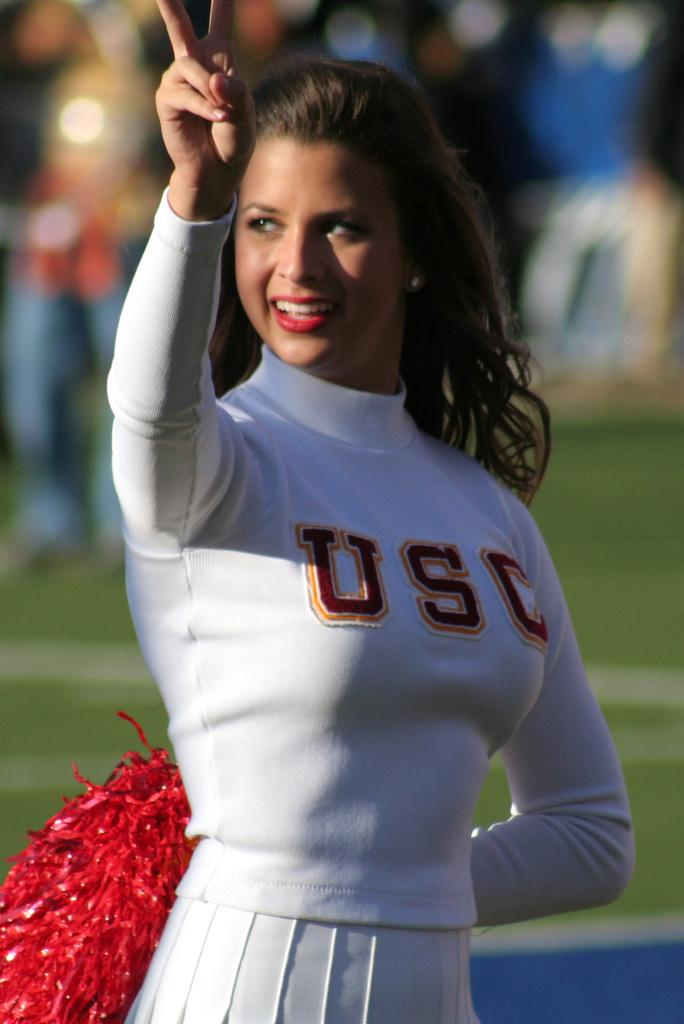<image>
Give a short and clear explanation of the subsequent image. A brunette cheerleader from USC with red pom poms. 